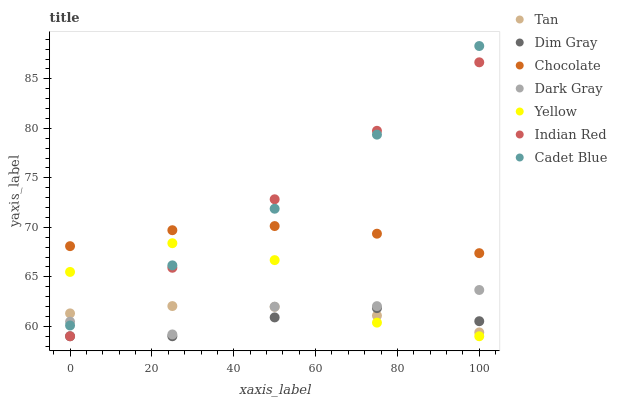Does Dim Gray have the minimum area under the curve?
Answer yes or no. Yes. Does Cadet Blue have the maximum area under the curve?
Answer yes or no. Yes. Does Yellow have the minimum area under the curve?
Answer yes or no. No. Does Yellow have the maximum area under the curve?
Answer yes or no. No. Is Indian Red the smoothest?
Answer yes or no. Yes. Is Yellow the roughest?
Answer yes or no. Yes. Is Chocolate the smoothest?
Answer yes or no. No. Is Chocolate the roughest?
Answer yes or no. No. Does Dim Gray have the lowest value?
Answer yes or no. Yes. Does Chocolate have the lowest value?
Answer yes or no. No. Does Cadet Blue have the highest value?
Answer yes or no. Yes. Does Yellow have the highest value?
Answer yes or no. No. Is Dark Gray less than Chocolate?
Answer yes or no. Yes. Is Chocolate greater than Tan?
Answer yes or no. Yes. Does Dark Gray intersect Yellow?
Answer yes or no. Yes. Is Dark Gray less than Yellow?
Answer yes or no. No. Is Dark Gray greater than Yellow?
Answer yes or no. No. Does Dark Gray intersect Chocolate?
Answer yes or no. No. 